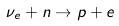Convert formula to latex. <formula><loc_0><loc_0><loc_500><loc_500>\nu _ { e } + n \rightarrow p + e</formula> 